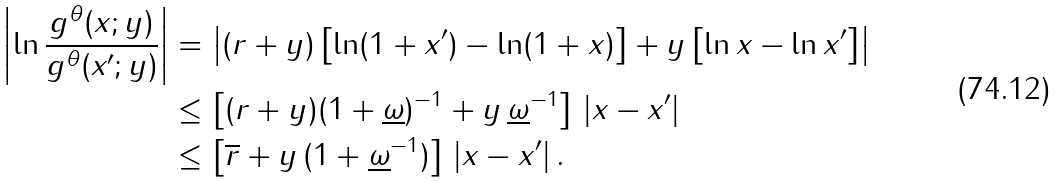<formula> <loc_0><loc_0><loc_500><loc_500>\left | \ln \frac { g ^ { \theta } ( x ; y ) } { g ^ { \theta } ( x ^ { \prime } ; y ) } \right | & = \left | ( r + y ) \left [ \ln ( 1 + x ^ { \prime } ) - \ln ( 1 + x ) \right ] + y \left [ \ln x - \ln x ^ { \prime } \right ] \right | \\ & \leq \left [ ( r + y ) ( 1 + \underline { \omega } ) ^ { - 1 } + y \, \underline { \omega } ^ { - 1 } \right ] \, | x - x ^ { \prime } | \\ & \leq \left [ \overline { r } + y \, ( 1 + \underline { \omega } ^ { - 1 } ) \right ] \, | x - x ^ { \prime } | \, .</formula> 